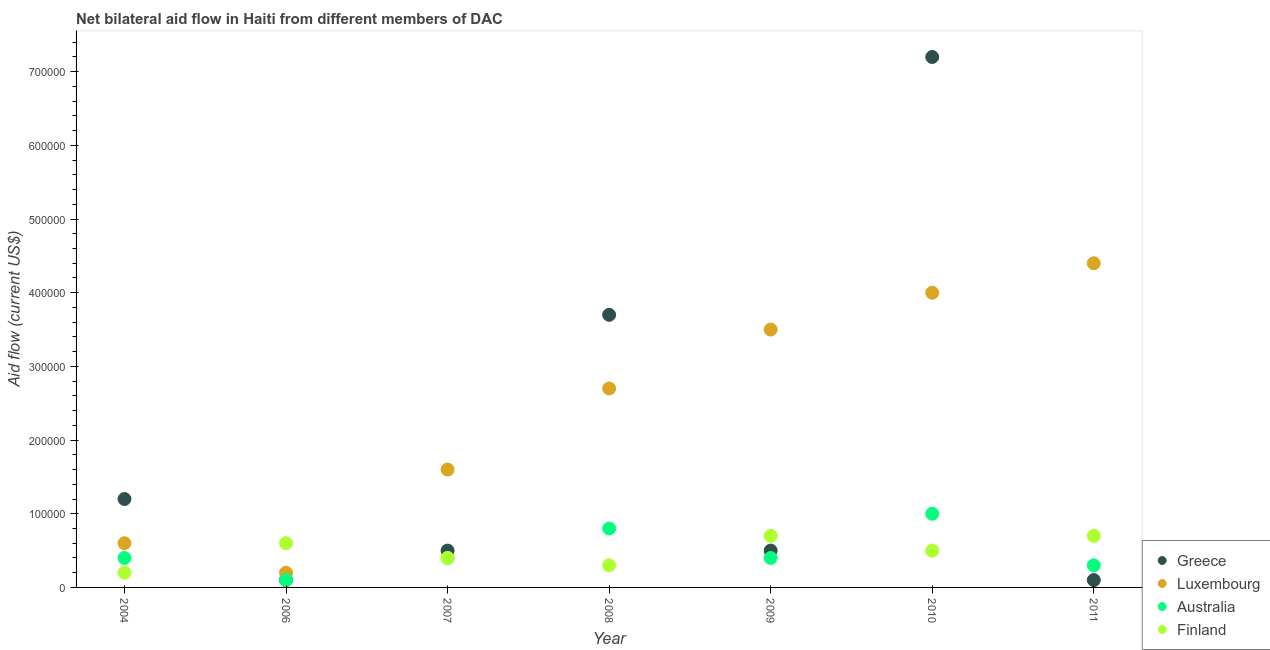What is the amount of aid given by luxembourg in 2004?
Your answer should be compact. 6.00e+04. Across all years, what is the maximum amount of aid given by finland?
Your answer should be compact. 7.00e+04. Across all years, what is the minimum amount of aid given by australia?
Offer a terse response. 10000. In which year was the amount of aid given by finland minimum?
Provide a short and direct response. 2004. What is the total amount of aid given by luxembourg in the graph?
Give a very brief answer. 1.70e+06. What is the difference between the amount of aid given by australia in 2011 and the amount of aid given by greece in 2004?
Ensure brevity in your answer.  -9.00e+04. What is the average amount of aid given by australia per year?
Your answer should be very brief. 4.86e+04. In the year 2006, what is the difference between the amount of aid given by greece and amount of aid given by australia?
Provide a short and direct response. 0. In how many years, is the amount of aid given by australia greater than 240000 US$?
Give a very brief answer. 0. What is the ratio of the amount of aid given by luxembourg in 2007 to that in 2008?
Give a very brief answer. 0.59. Is the amount of aid given by finland in 2006 less than that in 2010?
Keep it short and to the point. No. What is the difference between the highest and the lowest amount of aid given by australia?
Make the answer very short. 9.00e+04. Is the sum of the amount of aid given by finland in 2004 and 2011 greater than the maximum amount of aid given by australia across all years?
Give a very brief answer. No. Is it the case that in every year, the sum of the amount of aid given by greece and amount of aid given by luxembourg is greater than the amount of aid given by australia?
Provide a succinct answer. Yes. Is the amount of aid given by australia strictly less than the amount of aid given by finland over the years?
Your answer should be very brief. No. How many dotlines are there?
Give a very brief answer. 4. How many years are there in the graph?
Your response must be concise. 7. What is the difference between two consecutive major ticks on the Y-axis?
Make the answer very short. 1.00e+05. Does the graph contain any zero values?
Your answer should be compact. No. Does the graph contain grids?
Your answer should be very brief. No. What is the title of the graph?
Your response must be concise. Net bilateral aid flow in Haiti from different members of DAC. What is the label or title of the X-axis?
Your response must be concise. Year. What is the label or title of the Y-axis?
Give a very brief answer. Aid flow (current US$). What is the Aid flow (current US$) in Australia in 2004?
Provide a short and direct response. 4.00e+04. What is the Aid flow (current US$) of Finland in 2004?
Your answer should be compact. 2.00e+04. What is the Aid flow (current US$) in Greece in 2006?
Your answer should be compact. 10000. What is the Aid flow (current US$) of Luxembourg in 2006?
Offer a very short reply. 2.00e+04. What is the Aid flow (current US$) in Australia in 2006?
Make the answer very short. 10000. What is the Aid flow (current US$) of Greece in 2007?
Keep it short and to the point. 5.00e+04. What is the Aid flow (current US$) in Australia in 2007?
Your answer should be compact. 4.00e+04. What is the Aid flow (current US$) of Greece in 2008?
Provide a succinct answer. 3.70e+05. What is the Aid flow (current US$) of Luxembourg in 2008?
Your response must be concise. 2.70e+05. What is the Aid flow (current US$) of Finland in 2008?
Ensure brevity in your answer.  3.00e+04. What is the Aid flow (current US$) of Greece in 2009?
Make the answer very short. 5.00e+04. What is the Aid flow (current US$) in Luxembourg in 2009?
Provide a short and direct response. 3.50e+05. What is the Aid flow (current US$) in Finland in 2009?
Keep it short and to the point. 7.00e+04. What is the Aid flow (current US$) in Greece in 2010?
Provide a short and direct response. 7.20e+05. What is the Aid flow (current US$) of Luxembourg in 2010?
Make the answer very short. 4.00e+05. What is the Aid flow (current US$) in Australia in 2010?
Keep it short and to the point. 1.00e+05. What is the Aid flow (current US$) of Finland in 2010?
Your response must be concise. 5.00e+04. What is the Aid flow (current US$) of Finland in 2011?
Offer a very short reply. 7.00e+04. Across all years, what is the maximum Aid flow (current US$) of Greece?
Provide a short and direct response. 7.20e+05. Across all years, what is the maximum Aid flow (current US$) of Australia?
Keep it short and to the point. 1.00e+05. Across all years, what is the maximum Aid flow (current US$) in Finland?
Your answer should be compact. 7.00e+04. Across all years, what is the minimum Aid flow (current US$) of Greece?
Ensure brevity in your answer.  10000. What is the total Aid flow (current US$) of Greece in the graph?
Provide a short and direct response. 1.33e+06. What is the total Aid flow (current US$) of Luxembourg in the graph?
Provide a short and direct response. 1.70e+06. What is the difference between the Aid flow (current US$) of Greece in 2004 and that in 2006?
Make the answer very short. 1.10e+05. What is the difference between the Aid flow (current US$) of Luxembourg in 2004 and that in 2006?
Your answer should be compact. 4.00e+04. What is the difference between the Aid flow (current US$) of Australia in 2004 and that in 2006?
Keep it short and to the point. 3.00e+04. What is the difference between the Aid flow (current US$) of Finland in 2004 and that in 2006?
Make the answer very short. -4.00e+04. What is the difference between the Aid flow (current US$) of Luxembourg in 2004 and that in 2007?
Give a very brief answer. -1.00e+05. What is the difference between the Aid flow (current US$) of Australia in 2004 and that in 2007?
Your answer should be very brief. 0. What is the difference between the Aid flow (current US$) in Finland in 2004 and that in 2007?
Your answer should be compact. -2.00e+04. What is the difference between the Aid flow (current US$) in Greece in 2004 and that in 2008?
Provide a succinct answer. -2.50e+05. What is the difference between the Aid flow (current US$) in Greece in 2004 and that in 2009?
Give a very brief answer. 7.00e+04. What is the difference between the Aid flow (current US$) in Finland in 2004 and that in 2009?
Keep it short and to the point. -5.00e+04. What is the difference between the Aid flow (current US$) in Greece in 2004 and that in 2010?
Keep it short and to the point. -6.00e+05. What is the difference between the Aid flow (current US$) of Luxembourg in 2004 and that in 2010?
Provide a succinct answer. -3.40e+05. What is the difference between the Aid flow (current US$) in Luxembourg in 2004 and that in 2011?
Make the answer very short. -3.80e+05. What is the difference between the Aid flow (current US$) in Finland in 2004 and that in 2011?
Your response must be concise. -5.00e+04. What is the difference between the Aid flow (current US$) in Luxembourg in 2006 and that in 2007?
Your answer should be compact. -1.40e+05. What is the difference between the Aid flow (current US$) of Finland in 2006 and that in 2007?
Offer a very short reply. 2.00e+04. What is the difference between the Aid flow (current US$) of Greece in 2006 and that in 2008?
Your response must be concise. -3.60e+05. What is the difference between the Aid flow (current US$) in Australia in 2006 and that in 2008?
Your answer should be very brief. -7.00e+04. What is the difference between the Aid flow (current US$) in Luxembourg in 2006 and that in 2009?
Make the answer very short. -3.30e+05. What is the difference between the Aid flow (current US$) of Australia in 2006 and that in 2009?
Provide a short and direct response. -3.00e+04. What is the difference between the Aid flow (current US$) of Greece in 2006 and that in 2010?
Provide a succinct answer. -7.10e+05. What is the difference between the Aid flow (current US$) of Luxembourg in 2006 and that in 2010?
Your answer should be very brief. -3.80e+05. What is the difference between the Aid flow (current US$) in Australia in 2006 and that in 2010?
Provide a succinct answer. -9.00e+04. What is the difference between the Aid flow (current US$) in Finland in 2006 and that in 2010?
Give a very brief answer. 10000. What is the difference between the Aid flow (current US$) in Greece in 2006 and that in 2011?
Offer a terse response. 0. What is the difference between the Aid flow (current US$) in Luxembourg in 2006 and that in 2011?
Offer a terse response. -4.20e+05. What is the difference between the Aid flow (current US$) of Australia in 2006 and that in 2011?
Your response must be concise. -2.00e+04. What is the difference between the Aid flow (current US$) of Greece in 2007 and that in 2008?
Give a very brief answer. -3.20e+05. What is the difference between the Aid flow (current US$) in Australia in 2007 and that in 2008?
Offer a very short reply. -4.00e+04. What is the difference between the Aid flow (current US$) of Finland in 2007 and that in 2008?
Your answer should be very brief. 10000. What is the difference between the Aid flow (current US$) of Luxembourg in 2007 and that in 2009?
Keep it short and to the point. -1.90e+05. What is the difference between the Aid flow (current US$) of Australia in 2007 and that in 2009?
Provide a succinct answer. 0. What is the difference between the Aid flow (current US$) in Greece in 2007 and that in 2010?
Keep it short and to the point. -6.70e+05. What is the difference between the Aid flow (current US$) in Australia in 2007 and that in 2010?
Your answer should be compact. -6.00e+04. What is the difference between the Aid flow (current US$) of Greece in 2007 and that in 2011?
Provide a short and direct response. 4.00e+04. What is the difference between the Aid flow (current US$) in Luxembourg in 2007 and that in 2011?
Offer a very short reply. -2.80e+05. What is the difference between the Aid flow (current US$) of Finland in 2008 and that in 2009?
Offer a terse response. -4.00e+04. What is the difference between the Aid flow (current US$) of Greece in 2008 and that in 2010?
Keep it short and to the point. -3.50e+05. What is the difference between the Aid flow (current US$) in Luxembourg in 2008 and that in 2010?
Ensure brevity in your answer.  -1.30e+05. What is the difference between the Aid flow (current US$) in Greece in 2008 and that in 2011?
Ensure brevity in your answer.  3.60e+05. What is the difference between the Aid flow (current US$) in Luxembourg in 2008 and that in 2011?
Offer a very short reply. -1.70e+05. What is the difference between the Aid flow (current US$) in Greece in 2009 and that in 2010?
Your response must be concise. -6.70e+05. What is the difference between the Aid flow (current US$) in Greece in 2009 and that in 2011?
Give a very brief answer. 4.00e+04. What is the difference between the Aid flow (current US$) of Luxembourg in 2009 and that in 2011?
Your answer should be compact. -9.00e+04. What is the difference between the Aid flow (current US$) of Greece in 2010 and that in 2011?
Offer a terse response. 7.10e+05. What is the difference between the Aid flow (current US$) of Luxembourg in 2010 and that in 2011?
Ensure brevity in your answer.  -4.00e+04. What is the difference between the Aid flow (current US$) in Finland in 2010 and that in 2011?
Ensure brevity in your answer.  -2.00e+04. What is the difference between the Aid flow (current US$) in Greece in 2004 and the Aid flow (current US$) in Luxembourg in 2006?
Your response must be concise. 1.00e+05. What is the difference between the Aid flow (current US$) of Greece in 2004 and the Aid flow (current US$) of Australia in 2007?
Offer a very short reply. 8.00e+04. What is the difference between the Aid flow (current US$) of Greece in 2004 and the Aid flow (current US$) of Finland in 2007?
Make the answer very short. 8.00e+04. What is the difference between the Aid flow (current US$) in Luxembourg in 2004 and the Aid flow (current US$) in Australia in 2007?
Your answer should be compact. 2.00e+04. What is the difference between the Aid flow (current US$) in Australia in 2004 and the Aid flow (current US$) in Finland in 2007?
Your response must be concise. 0. What is the difference between the Aid flow (current US$) of Greece in 2004 and the Aid flow (current US$) of Luxembourg in 2008?
Provide a short and direct response. -1.50e+05. What is the difference between the Aid flow (current US$) of Greece in 2004 and the Aid flow (current US$) of Australia in 2008?
Make the answer very short. 4.00e+04. What is the difference between the Aid flow (current US$) in Luxembourg in 2004 and the Aid flow (current US$) in Australia in 2008?
Your answer should be compact. -2.00e+04. What is the difference between the Aid flow (current US$) in Greece in 2004 and the Aid flow (current US$) in Luxembourg in 2009?
Give a very brief answer. -2.30e+05. What is the difference between the Aid flow (current US$) of Greece in 2004 and the Aid flow (current US$) of Australia in 2009?
Offer a very short reply. 8.00e+04. What is the difference between the Aid flow (current US$) in Greece in 2004 and the Aid flow (current US$) in Finland in 2009?
Your answer should be very brief. 5.00e+04. What is the difference between the Aid flow (current US$) of Australia in 2004 and the Aid flow (current US$) of Finland in 2009?
Ensure brevity in your answer.  -3.00e+04. What is the difference between the Aid flow (current US$) of Greece in 2004 and the Aid flow (current US$) of Luxembourg in 2010?
Your response must be concise. -2.80e+05. What is the difference between the Aid flow (current US$) of Greece in 2004 and the Aid flow (current US$) of Australia in 2010?
Your answer should be compact. 2.00e+04. What is the difference between the Aid flow (current US$) of Greece in 2004 and the Aid flow (current US$) of Finland in 2010?
Make the answer very short. 7.00e+04. What is the difference between the Aid flow (current US$) of Luxembourg in 2004 and the Aid flow (current US$) of Australia in 2010?
Offer a very short reply. -4.00e+04. What is the difference between the Aid flow (current US$) of Luxembourg in 2004 and the Aid flow (current US$) of Finland in 2010?
Keep it short and to the point. 10000. What is the difference between the Aid flow (current US$) in Australia in 2004 and the Aid flow (current US$) in Finland in 2010?
Offer a very short reply. -10000. What is the difference between the Aid flow (current US$) of Greece in 2004 and the Aid flow (current US$) of Luxembourg in 2011?
Provide a succinct answer. -3.20e+05. What is the difference between the Aid flow (current US$) in Greece in 2004 and the Aid flow (current US$) in Australia in 2011?
Keep it short and to the point. 9.00e+04. What is the difference between the Aid flow (current US$) in Greece in 2004 and the Aid flow (current US$) in Finland in 2011?
Your answer should be compact. 5.00e+04. What is the difference between the Aid flow (current US$) of Luxembourg in 2004 and the Aid flow (current US$) of Australia in 2011?
Offer a very short reply. 3.00e+04. What is the difference between the Aid flow (current US$) in Greece in 2006 and the Aid flow (current US$) in Australia in 2007?
Make the answer very short. -3.00e+04. What is the difference between the Aid flow (current US$) in Greece in 2006 and the Aid flow (current US$) in Finland in 2007?
Offer a terse response. -3.00e+04. What is the difference between the Aid flow (current US$) in Luxembourg in 2006 and the Aid flow (current US$) in Finland in 2007?
Your answer should be compact. -2.00e+04. What is the difference between the Aid flow (current US$) of Australia in 2006 and the Aid flow (current US$) of Finland in 2007?
Offer a terse response. -3.00e+04. What is the difference between the Aid flow (current US$) of Greece in 2006 and the Aid flow (current US$) of Australia in 2008?
Make the answer very short. -7.00e+04. What is the difference between the Aid flow (current US$) in Greece in 2006 and the Aid flow (current US$) in Finland in 2008?
Your response must be concise. -2.00e+04. What is the difference between the Aid flow (current US$) in Luxembourg in 2006 and the Aid flow (current US$) in Australia in 2008?
Offer a very short reply. -6.00e+04. What is the difference between the Aid flow (current US$) in Luxembourg in 2006 and the Aid flow (current US$) in Finland in 2008?
Give a very brief answer. -10000. What is the difference between the Aid flow (current US$) in Australia in 2006 and the Aid flow (current US$) in Finland in 2008?
Offer a terse response. -2.00e+04. What is the difference between the Aid flow (current US$) in Greece in 2006 and the Aid flow (current US$) in Finland in 2009?
Ensure brevity in your answer.  -6.00e+04. What is the difference between the Aid flow (current US$) of Luxembourg in 2006 and the Aid flow (current US$) of Finland in 2009?
Ensure brevity in your answer.  -5.00e+04. What is the difference between the Aid flow (current US$) in Australia in 2006 and the Aid flow (current US$) in Finland in 2009?
Offer a very short reply. -6.00e+04. What is the difference between the Aid flow (current US$) of Greece in 2006 and the Aid flow (current US$) of Luxembourg in 2010?
Your answer should be compact. -3.90e+05. What is the difference between the Aid flow (current US$) in Australia in 2006 and the Aid flow (current US$) in Finland in 2010?
Provide a succinct answer. -4.00e+04. What is the difference between the Aid flow (current US$) in Greece in 2006 and the Aid flow (current US$) in Luxembourg in 2011?
Provide a succinct answer. -4.30e+05. What is the difference between the Aid flow (current US$) of Greece in 2006 and the Aid flow (current US$) of Australia in 2011?
Offer a very short reply. -2.00e+04. What is the difference between the Aid flow (current US$) of Luxembourg in 2006 and the Aid flow (current US$) of Australia in 2011?
Offer a very short reply. -10000. What is the difference between the Aid flow (current US$) in Australia in 2006 and the Aid flow (current US$) in Finland in 2011?
Offer a very short reply. -6.00e+04. What is the difference between the Aid flow (current US$) in Greece in 2007 and the Aid flow (current US$) in Australia in 2008?
Provide a succinct answer. -3.00e+04. What is the difference between the Aid flow (current US$) in Greece in 2007 and the Aid flow (current US$) in Finland in 2008?
Offer a terse response. 2.00e+04. What is the difference between the Aid flow (current US$) of Luxembourg in 2007 and the Aid flow (current US$) of Finland in 2008?
Provide a succinct answer. 1.30e+05. What is the difference between the Aid flow (current US$) in Australia in 2007 and the Aid flow (current US$) in Finland in 2008?
Provide a short and direct response. 10000. What is the difference between the Aid flow (current US$) in Luxembourg in 2007 and the Aid flow (current US$) in Australia in 2009?
Provide a succinct answer. 1.20e+05. What is the difference between the Aid flow (current US$) of Greece in 2007 and the Aid flow (current US$) of Luxembourg in 2010?
Make the answer very short. -3.50e+05. What is the difference between the Aid flow (current US$) of Luxembourg in 2007 and the Aid flow (current US$) of Finland in 2010?
Offer a very short reply. 1.10e+05. What is the difference between the Aid flow (current US$) of Australia in 2007 and the Aid flow (current US$) of Finland in 2010?
Your answer should be compact. -10000. What is the difference between the Aid flow (current US$) in Greece in 2007 and the Aid flow (current US$) in Luxembourg in 2011?
Your response must be concise. -3.90e+05. What is the difference between the Aid flow (current US$) of Luxembourg in 2007 and the Aid flow (current US$) of Australia in 2011?
Make the answer very short. 1.30e+05. What is the difference between the Aid flow (current US$) in Luxembourg in 2008 and the Aid flow (current US$) in Finland in 2009?
Ensure brevity in your answer.  2.00e+05. What is the difference between the Aid flow (current US$) of Australia in 2008 and the Aid flow (current US$) of Finland in 2009?
Ensure brevity in your answer.  10000. What is the difference between the Aid flow (current US$) in Greece in 2008 and the Aid flow (current US$) in Luxembourg in 2010?
Your answer should be compact. -3.00e+04. What is the difference between the Aid flow (current US$) of Greece in 2008 and the Aid flow (current US$) of Australia in 2010?
Your answer should be compact. 2.70e+05. What is the difference between the Aid flow (current US$) of Greece in 2008 and the Aid flow (current US$) of Finland in 2010?
Your answer should be very brief. 3.20e+05. What is the difference between the Aid flow (current US$) of Australia in 2008 and the Aid flow (current US$) of Finland in 2010?
Offer a terse response. 3.00e+04. What is the difference between the Aid flow (current US$) of Greece in 2008 and the Aid flow (current US$) of Australia in 2011?
Make the answer very short. 3.40e+05. What is the difference between the Aid flow (current US$) in Luxembourg in 2008 and the Aid flow (current US$) in Finland in 2011?
Your answer should be compact. 2.00e+05. What is the difference between the Aid flow (current US$) in Australia in 2008 and the Aid flow (current US$) in Finland in 2011?
Provide a short and direct response. 10000. What is the difference between the Aid flow (current US$) of Greece in 2009 and the Aid flow (current US$) of Luxembourg in 2010?
Your answer should be compact. -3.50e+05. What is the difference between the Aid flow (current US$) of Luxembourg in 2009 and the Aid flow (current US$) of Finland in 2010?
Make the answer very short. 3.00e+05. What is the difference between the Aid flow (current US$) in Greece in 2009 and the Aid flow (current US$) in Luxembourg in 2011?
Make the answer very short. -3.90e+05. What is the difference between the Aid flow (current US$) in Greece in 2009 and the Aid flow (current US$) in Finland in 2011?
Your answer should be compact. -2.00e+04. What is the difference between the Aid flow (current US$) in Luxembourg in 2009 and the Aid flow (current US$) in Finland in 2011?
Your answer should be compact. 2.80e+05. What is the difference between the Aid flow (current US$) of Greece in 2010 and the Aid flow (current US$) of Luxembourg in 2011?
Ensure brevity in your answer.  2.80e+05. What is the difference between the Aid flow (current US$) of Greece in 2010 and the Aid flow (current US$) of Australia in 2011?
Give a very brief answer. 6.90e+05. What is the difference between the Aid flow (current US$) of Greece in 2010 and the Aid flow (current US$) of Finland in 2011?
Ensure brevity in your answer.  6.50e+05. What is the difference between the Aid flow (current US$) of Luxembourg in 2010 and the Aid flow (current US$) of Australia in 2011?
Ensure brevity in your answer.  3.70e+05. What is the difference between the Aid flow (current US$) of Luxembourg in 2010 and the Aid flow (current US$) of Finland in 2011?
Your response must be concise. 3.30e+05. What is the average Aid flow (current US$) of Greece per year?
Provide a succinct answer. 1.90e+05. What is the average Aid flow (current US$) in Luxembourg per year?
Offer a very short reply. 2.43e+05. What is the average Aid flow (current US$) of Australia per year?
Offer a terse response. 4.86e+04. What is the average Aid flow (current US$) of Finland per year?
Give a very brief answer. 4.86e+04. In the year 2004, what is the difference between the Aid flow (current US$) in Greece and Aid flow (current US$) in Finland?
Your answer should be compact. 1.00e+05. In the year 2004, what is the difference between the Aid flow (current US$) of Luxembourg and Aid flow (current US$) of Finland?
Make the answer very short. 4.00e+04. In the year 2006, what is the difference between the Aid flow (current US$) in Greece and Aid flow (current US$) in Luxembourg?
Keep it short and to the point. -10000. In the year 2006, what is the difference between the Aid flow (current US$) of Greece and Aid flow (current US$) of Finland?
Keep it short and to the point. -5.00e+04. In the year 2007, what is the difference between the Aid flow (current US$) in Greece and Aid flow (current US$) in Luxembourg?
Your answer should be very brief. -1.10e+05. In the year 2007, what is the difference between the Aid flow (current US$) in Greece and Aid flow (current US$) in Australia?
Offer a very short reply. 10000. In the year 2007, what is the difference between the Aid flow (current US$) of Greece and Aid flow (current US$) of Finland?
Make the answer very short. 10000. In the year 2007, what is the difference between the Aid flow (current US$) of Luxembourg and Aid flow (current US$) of Finland?
Keep it short and to the point. 1.20e+05. In the year 2008, what is the difference between the Aid flow (current US$) in Greece and Aid flow (current US$) in Luxembourg?
Your answer should be compact. 1.00e+05. In the year 2008, what is the difference between the Aid flow (current US$) in Greece and Aid flow (current US$) in Australia?
Ensure brevity in your answer.  2.90e+05. In the year 2008, what is the difference between the Aid flow (current US$) in Luxembourg and Aid flow (current US$) in Finland?
Provide a short and direct response. 2.40e+05. In the year 2009, what is the difference between the Aid flow (current US$) of Greece and Aid flow (current US$) of Australia?
Make the answer very short. 10000. In the year 2010, what is the difference between the Aid flow (current US$) of Greece and Aid flow (current US$) of Luxembourg?
Your response must be concise. 3.20e+05. In the year 2010, what is the difference between the Aid flow (current US$) in Greece and Aid flow (current US$) in Australia?
Give a very brief answer. 6.20e+05. In the year 2010, what is the difference between the Aid flow (current US$) of Greece and Aid flow (current US$) of Finland?
Your answer should be very brief. 6.70e+05. In the year 2010, what is the difference between the Aid flow (current US$) of Luxembourg and Aid flow (current US$) of Australia?
Ensure brevity in your answer.  3.00e+05. In the year 2010, what is the difference between the Aid flow (current US$) of Australia and Aid flow (current US$) of Finland?
Offer a very short reply. 5.00e+04. In the year 2011, what is the difference between the Aid flow (current US$) in Greece and Aid flow (current US$) in Luxembourg?
Offer a very short reply. -4.30e+05. In the year 2011, what is the difference between the Aid flow (current US$) of Greece and Aid flow (current US$) of Australia?
Ensure brevity in your answer.  -2.00e+04. In the year 2011, what is the difference between the Aid flow (current US$) in Greece and Aid flow (current US$) in Finland?
Offer a very short reply. -6.00e+04. In the year 2011, what is the difference between the Aid flow (current US$) of Luxembourg and Aid flow (current US$) of Australia?
Offer a terse response. 4.10e+05. In the year 2011, what is the difference between the Aid flow (current US$) of Australia and Aid flow (current US$) of Finland?
Provide a short and direct response. -4.00e+04. What is the ratio of the Aid flow (current US$) in Finland in 2004 to that in 2007?
Give a very brief answer. 0.5. What is the ratio of the Aid flow (current US$) of Greece in 2004 to that in 2008?
Your answer should be compact. 0.32. What is the ratio of the Aid flow (current US$) in Luxembourg in 2004 to that in 2008?
Offer a very short reply. 0.22. What is the ratio of the Aid flow (current US$) of Finland in 2004 to that in 2008?
Offer a terse response. 0.67. What is the ratio of the Aid flow (current US$) of Luxembourg in 2004 to that in 2009?
Keep it short and to the point. 0.17. What is the ratio of the Aid flow (current US$) of Australia in 2004 to that in 2009?
Give a very brief answer. 1. What is the ratio of the Aid flow (current US$) in Finland in 2004 to that in 2009?
Offer a very short reply. 0.29. What is the ratio of the Aid flow (current US$) in Greece in 2004 to that in 2010?
Your answer should be compact. 0.17. What is the ratio of the Aid flow (current US$) in Luxembourg in 2004 to that in 2010?
Make the answer very short. 0.15. What is the ratio of the Aid flow (current US$) in Australia in 2004 to that in 2010?
Your response must be concise. 0.4. What is the ratio of the Aid flow (current US$) in Luxembourg in 2004 to that in 2011?
Ensure brevity in your answer.  0.14. What is the ratio of the Aid flow (current US$) of Finland in 2004 to that in 2011?
Your response must be concise. 0.29. What is the ratio of the Aid flow (current US$) of Greece in 2006 to that in 2007?
Your answer should be compact. 0.2. What is the ratio of the Aid flow (current US$) of Luxembourg in 2006 to that in 2007?
Give a very brief answer. 0.12. What is the ratio of the Aid flow (current US$) in Finland in 2006 to that in 2007?
Your answer should be compact. 1.5. What is the ratio of the Aid flow (current US$) of Greece in 2006 to that in 2008?
Make the answer very short. 0.03. What is the ratio of the Aid flow (current US$) of Luxembourg in 2006 to that in 2008?
Make the answer very short. 0.07. What is the ratio of the Aid flow (current US$) in Finland in 2006 to that in 2008?
Your answer should be very brief. 2. What is the ratio of the Aid flow (current US$) in Luxembourg in 2006 to that in 2009?
Your response must be concise. 0.06. What is the ratio of the Aid flow (current US$) of Greece in 2006 to that in 2010?
Offer a very short reply. 0.01. What is the ratio of the Aid flow (current US$) in Australia in 2006 to that in 2010?
Your answer should be very brief. 0.1. What is the ratio of the Aid flow (current US$) of Luxembourg in 2006 to that in 2011?
Offer a terse response. 0.05. What is the ratio of the Aid flow (current US$) in Finland in 2006 to that in 2011?
Your answer should be very brief. 0.86. What is the ratio of the Aid flow (current US$) in Greece in 2007 to that in 2008?
Ensure brevity in your answer.  0.14. What is the ratio of the Aid flow (current US$) in Luxembourg in 2007 to that in 2008?
Give a very brief answer. 0.59. What is the ratio of the Aid flow (current US$) in Australia in 2007 to that in 2008?
Offer a very short reply. 0.5. What is the ratio of the Aid flow (current US$) in Finland in 2007 to that in 2008?
Your answer should be very brief. 1.33. What is the ratio of the Aid flow (current US$) of Luxembourg in 2007 to that in 2009?
Ensure brevity in your answer.  0.46. What is the ratio of the Aid flow (current US$) of Australia in 2007 to that in 2009?
Give a very brief answer. 1. What is the ratio of the Aid flow (current US$) of Finland in 2007 to that in 2009?
Your response must be concise. 0.57. What is the ratio of the Aid flow (current US$) in Greece in 2007 to that in 2010?
Your answer should be compact. 0.07. What is the ratio of the Aid flow (current US$) in Luxembourg in 2007 to that in 2010?
Make the answer very short. 0.4. What is the ratio of the Aid flow (current US$) in Finland in 2007 to that in 2010?
Ensure brevity in your answer.  0.8. What is the ratio of the Aid flow (current US$) in Luxembourg in 2007 to that in 2011?
Offer a terse response. 0.36. What is the ratio of the Aid flow (current US$) of Finland in 2007 to that in 2011?
Offer a terse response. 0.57. What is the ratio of the Aid flow (current US$) of Luxembourg in 2008 to that in 2009?
Keep it short and to the point. 0.77. What is the ratio of the Aid flow (current US$) in Finland in 2008 to that in 2009?
Provide a short and direct response. 0.43. What is the ratio of the Aid flow (current US$) in Greece in 2008 to that in 2010?
Provide a short and direct response. 0.51. What is the ratio of the Aid flow (current US$) in Luxembourg in 2008 to that in 2010?
Your answer should be very brief. 0.68. What is the ratio of the Aid flow (current US$) of Australia in 2008 to that in 2010?
Keep it short and to the point. 0.8. What is the ratio of the Aid flow (current US$) in Luxembourg in 2008 to that in 2011?
Provide a succinct answer. 0.61. What is the ratio of the Aid flow (current US$) of Australia in 2008 to that in 2011?
Offer a very short reply. 2.67. What is the ratio of the Aid flow (current US$) in Finland in 2008 to that in 2011?
Keep it short and to the point. 0.43. What is the ratio of the Aid flow (current US$) of Greece in 2009 to that in 2010?
Your answer should be very brief. 0.07. What is the ratio of the Aid flow (current US$) in Luxembourg in 2009 to that in 2010?
Keep it short and to the point. 0.88. What is the ratio of the Aid flow (current US$) in Luxembourg in 2009 to that in 2011?
Keep it short and to the point. 0.8. What is the ratio of the Aid flow (current US$) of Australia in 2009 to that in 2011?
Offer a very short reply. 1.33. What is the ratio of the Aid flow (current US$) of Greece in 2010 to that in 2011?
Your answer should be compact. 72. What is the ratio of the Aid flow (current US$) of Luxembourg in 2010 to that in 2011?
Your answer should be compact. 0.91. What is the ratio of the Aid flow (current US$) of Finland in 2010 to that in 2011?
Your response must be concise. 0.71. What is the difference between the highest and the second highest Aid flow (current US$) of Luxembourg?
Provide a succinct answer. 4.00e+04. What is the difference between the highest and the second highest Aid flow (current US$) of Australia?
Provide a short and direct response. 2.00e+04. What is the difference between the highest and the second highest Aid flow (current US$) in Finland?
Provide a short and direct response. 0. What is the difference between the highest and the lowest Aid flow (current US$) of Greece?
Provide a succinct answer. 7.10e+05. 